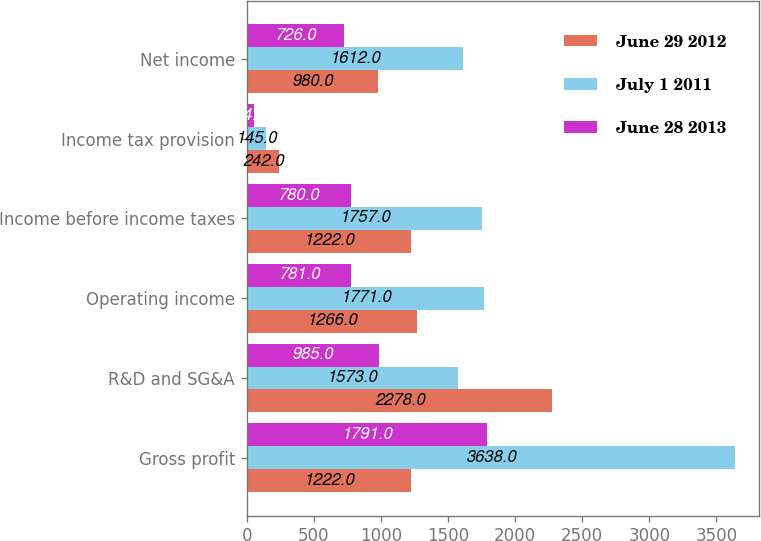Convert chart to OTSL. <chart><loc_0><loc_0><loc_500><loc_500><stacked_bar_chart><ecel><fcel>Gross profit<fcel>R&D and SG&A<fcel>Operating income<fcel>Income before income taxes<fcel>Income tax provision<fcel>Net income<nl><fcel>June 29 2012<fcel>1222<fcel>2278<fcel>1266<fcel>1222<fcel>242<fcel>980<nl><fcel>July 1 2011<fcel>3638<fcel>1573<fcel>1771<fcel>1757<fcel>145<fcel>1612<nl><fcel>June 28 2013<fcel>1791<fcel>985<fcel>781<fcel>780<fcel>54<fcel>726<nl></chart> 